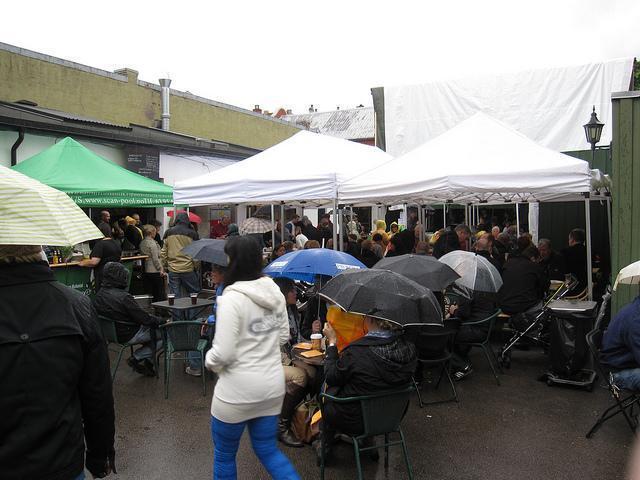Why is the outdoor area using covered gazebos?
Indicate the correct response and explain using: 'Answer: answer
Rationale: rationale.'
Options: Too icy, stay dry, too sunny, too windy. Answer: stay dry.
Rationale: The weather is overcast and the ground is wet. 